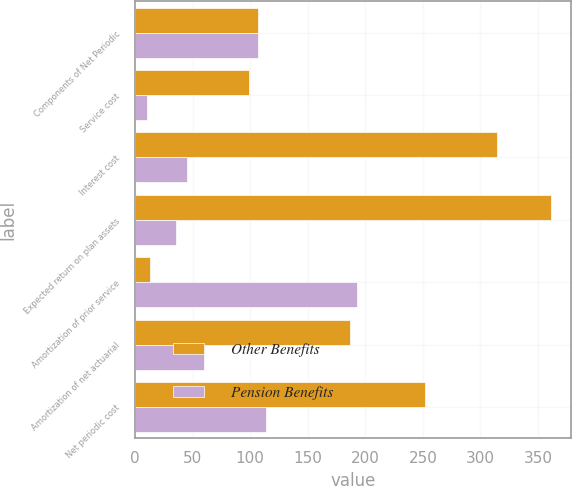<chart> <loc_0><loc_0><loc_500><loc_500><stacked_bar_chart><ecel><fcel>Components of Net Periodic<fcel>Service cost<fcel>Interest cost<fcel>Expected return on plan assets<fcel>Amortization of prior service<fcel>Amortization of net actuarial<fcel>Net periodic cost<nl><fcel>Other Benefits<fcel>106.5<fcel>99<fcel>314<fcel>361<fcel>13<fcel>187<fcel>252<nl><fcel>Pension Benefits<fcel>106.5<fcel>10<fcel>45<fcel>36<fcel>193<fcel>60<fcel>114<nl></chart> 